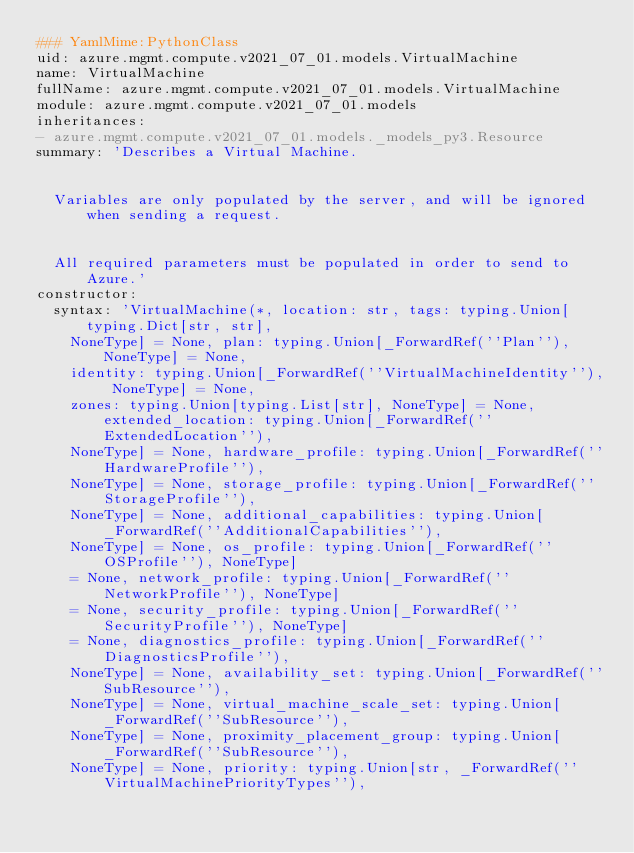Convert code to text. <code><loc_0><loc_0><loc_500><loc_500><_YAML_>### YamlMime:PythonClass
uid: azure.mgmt.compute.v2021_07_01.models.VirtualMachine
name: VirtualMachine
fullName: azure.mgmt.compute.v2021_07_01.models.VirtualMachine
module: azure.mgmt.compute.v2021_07_01.models
inheritances:
- azure.mgmt.compute.v2021_07_01.models._models_py3.Resource
summary: 'Describes a Virtual Machine.


  Variables are only populated by the server, and will be ignored when sending a request.


  All required parameters must be populated in order to send to Azure.'
constructor:
  syntax: 'VirtualMachine(*, location: str, tags: typing.Union[typing.Dict[str, str],
    NoneType] = None, plan: typing.Union[_ForwardRef(''Plan''), NoneType] = None,
    identity: typing.Union[_ForwardRef(''VirtualMachineIdentity''), NoneType] = None,
    zones: typing.Union[typing.List[str], NoneType] = None, extended_location: typing.Union[_ForwardRef(''ExtendedLocation''),
    NoneType] = None, hardware_profile: typing.Union[_ForwardRef(''HardwareProfile''),
    NoneType] = None, storage_profile: typing.Union[_ForwardRef(''StorageProfile''),
    NoneType] = None, additional_capabilities: typing.Union[_ForwardRef(''AdditionalCapabilities''),
    NoneType] = None, os_profile: typing.Union[_ForwardRef(''OSProfile''), NoneType]
    = None, network_profile: typing.Union[_ForwardRef(''NetworkProfile''), NoneType]
    = None, security_profile: typing.Union[_ForwardRef(''SecurityProfile''), NoneType]
    = None, diagnostics_profile: typing.Union[_ForwardRef(''DiagnosticsProfile''),
    NoneType] = None, availability_set: typing.Union[_ForwardRef(''SubResource''),
    NoneType] = None, virtual_machine_scale_set: typing.Union[_ForwardRef(''SubResource''),
    NoneType] = None, proximity_placement_group: typing.Union[_ForwardRef(''SubResource''),
    NoneType] = None, priority: typing.Union[str, _ForwardRef(''VirtualMachinePriorityTypes''),</code> 